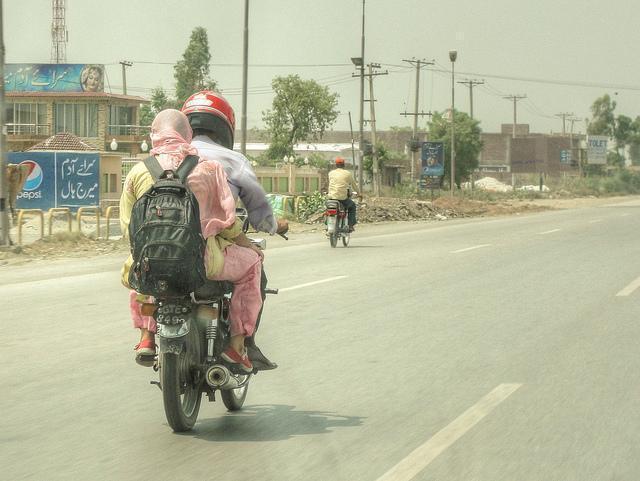Why is the air so hazy?
Choose the right answer from the provided options to respond to the question.
Options: Fire, factory smoke, smog, fog. Smog. 